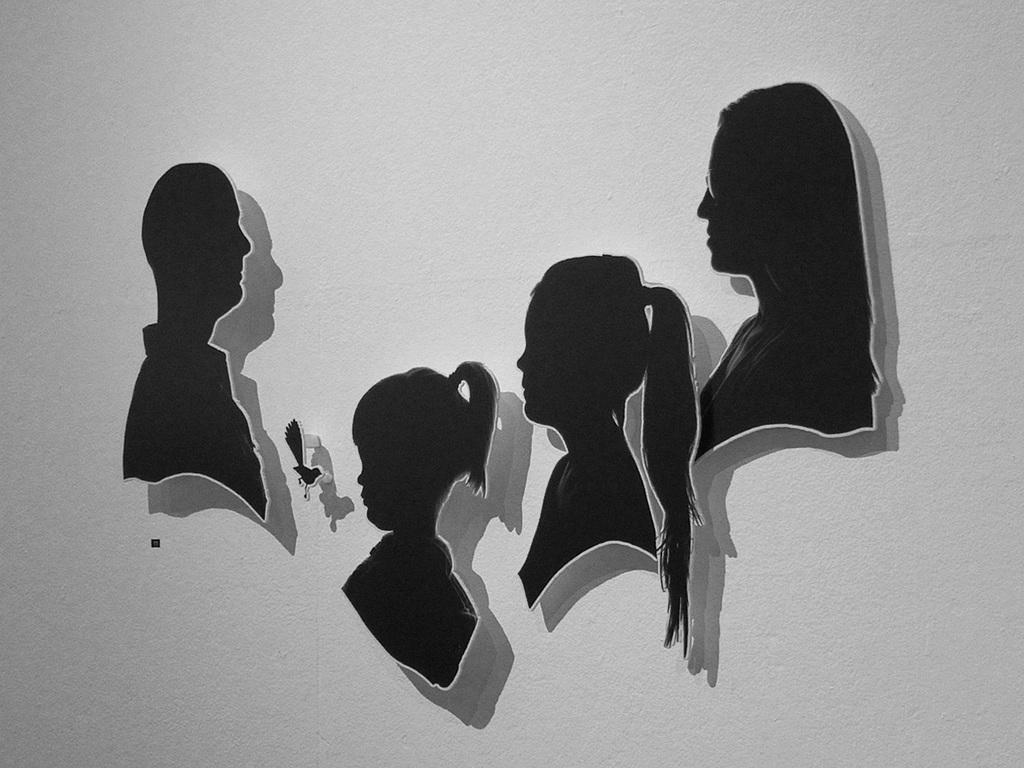What is the main subject of the image? There are human faces in the center of the image. What type of jellyfish can be seen swimming in the office during the rainstorm in the image? There is no jellyfish or office present in the image; it only features human faces. 